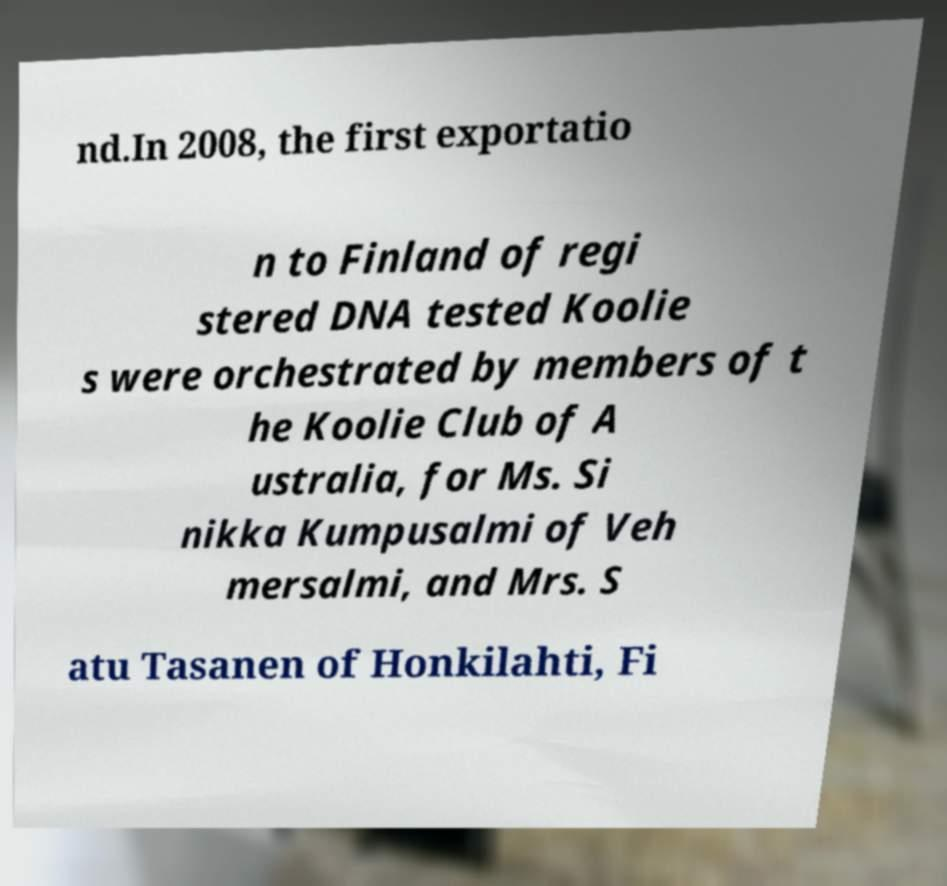There's text embedded in this image that I need extracted. Can you transcribe it verbatim? nd.In 2008, the first exportatio n to Finland of regi stered DNA tested Koolie s were orchestrated by members of t he Koolie Club of A ustralia, for Ms. Si nikka Kumpusalmi of Veh mersalmi, and Mrs. S atu Tasanen of Honkilahti, Fi 